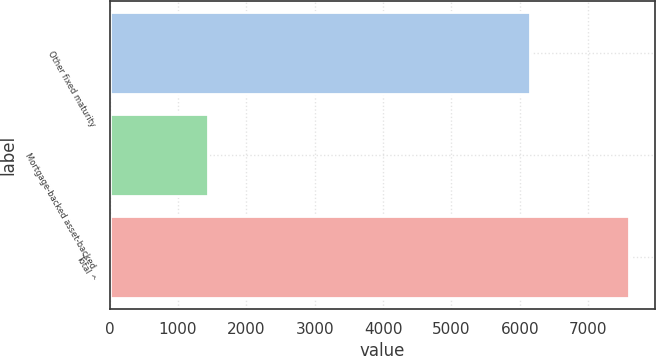Convert chart. <chart><loc_0><loc_0><loc_500><loc_500><bar_chart><fcel>Other fixed maturity<fcel>Mortgage-backed asset-backed<fcel>Total ^<nl><fcel>6151<fcel>1443<fcel>7594<nl></chart> 